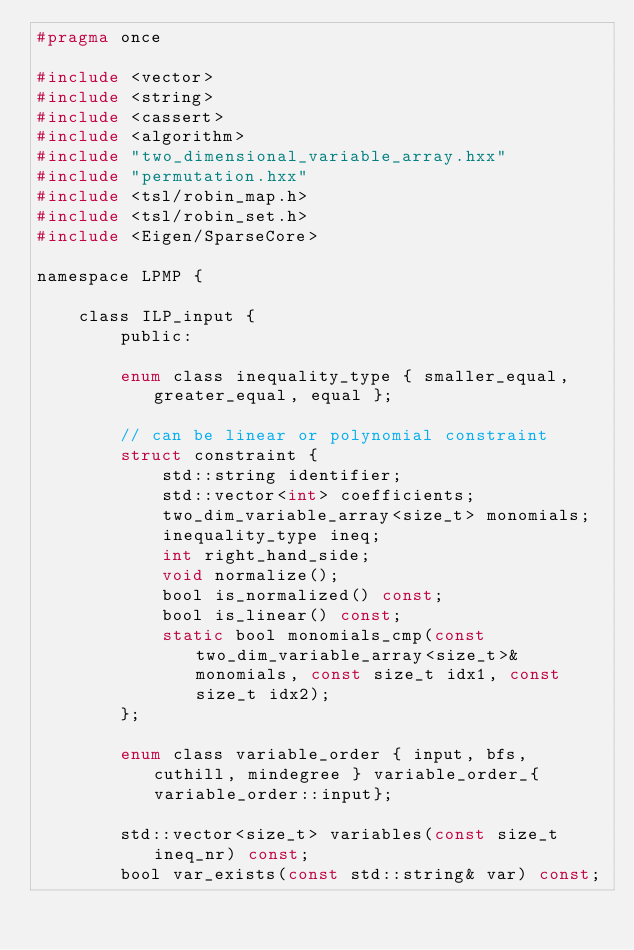Convert code to text. <code><loc_0><loc_0><loc_500><loc_500><_C_>#pragma once

#include <vector>
#include <string>
#include <cassert>
#include <algorithm>
#include "two_dimensional_variable_array.hxx"
#include "permutation.hxx"
#include <tsl/robin_map.h>
#include <tsl/robin_set.h>
#include <Eigen/SparseCore>

namespace LPMP {

    class ILP_input {
        public:

        enum class inequality_type { smaller_equal, greater_equal, equal };

        // can be linear or polynomial constraint
        struct constraint {
            std::string identifier;
            std::vector<int> coefficients;
            two_dim_variable_array<size_t> monomials;
            inequality_type ineq;
            int right_hand_side;
            void normalize();
            bool is_normalized() const;
            bool is_linear() const;
            static bool monomials_cmp(const two_dim_variable_array<size_t>& monomials, const size_t idx1, const size_t idx2);
        };

        enum class variable_order { input, bfs, cuthill, mindegree } variable_order_{variable_order::input};

        std::vector<size_t> variables(const size_t ineq_nr) const;
        bool var_exists(const std::string& var) const;</code> 